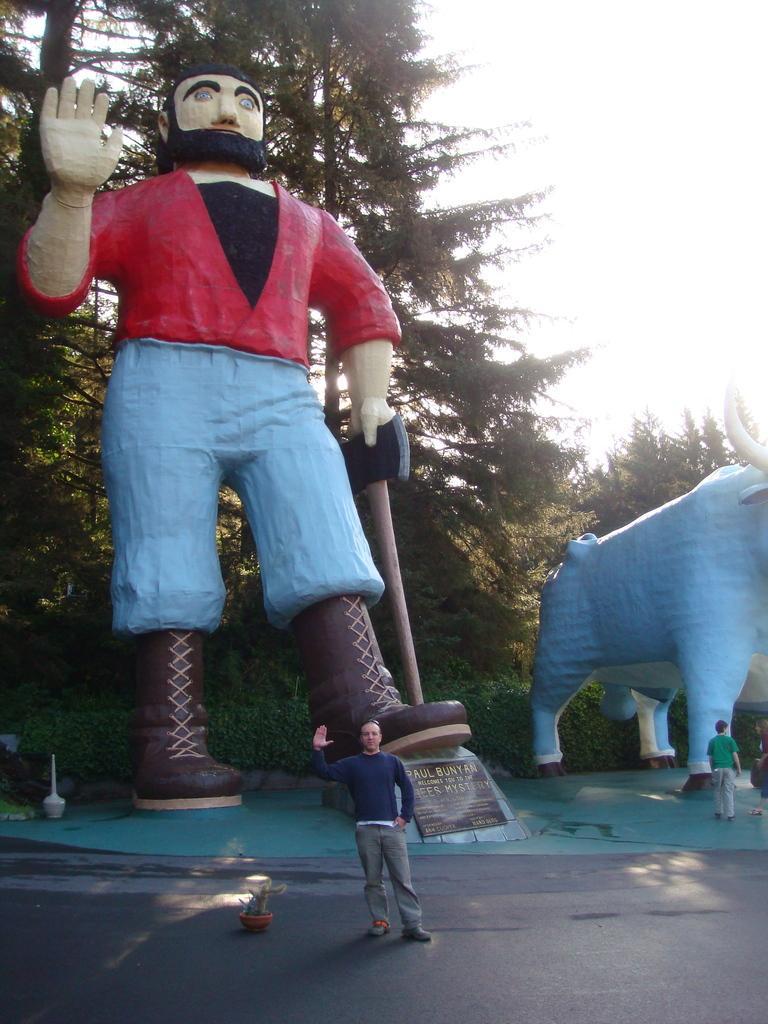Could you give a brief overview of what you see in this image? In this image there is a statue of a person holding a weapon and there is a statue of a bull, there are three people in front of the status, a flower pot on the road, few plants, trees and the sky. 